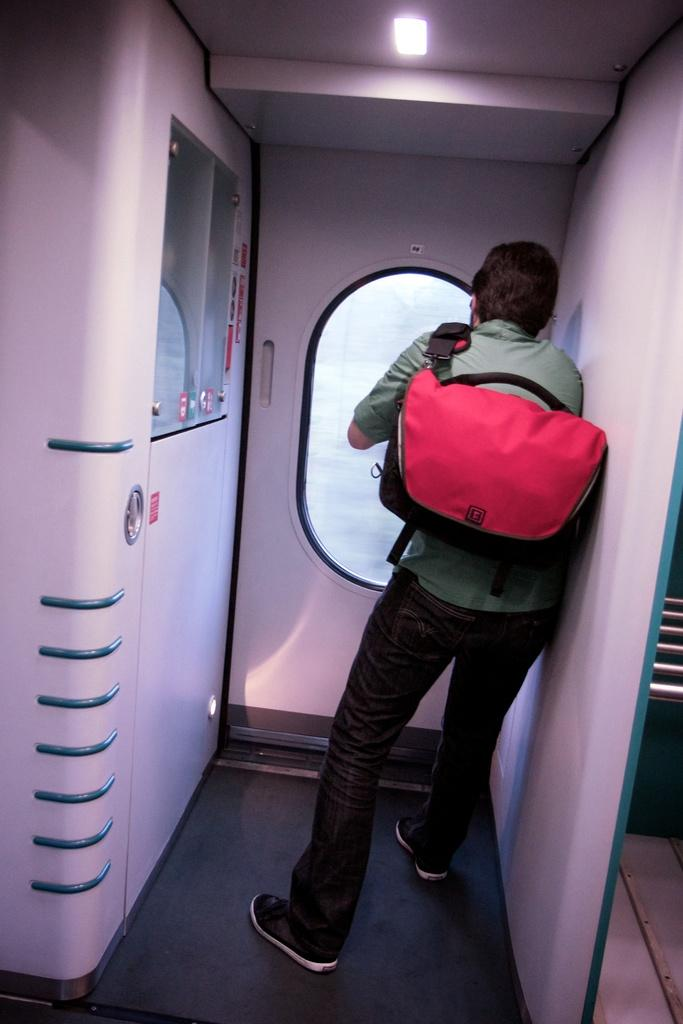What is present in the image? There is a person and a bag in the image. Can you describe the lighting in the image? Yes, there is light in the image. What type of quartz can be seen in the image? There is no quartz present in the image. What is the size of the person in the image? The size of the person cannot be determined from the image alone, as it depends on the perspective and distance from the camera. 